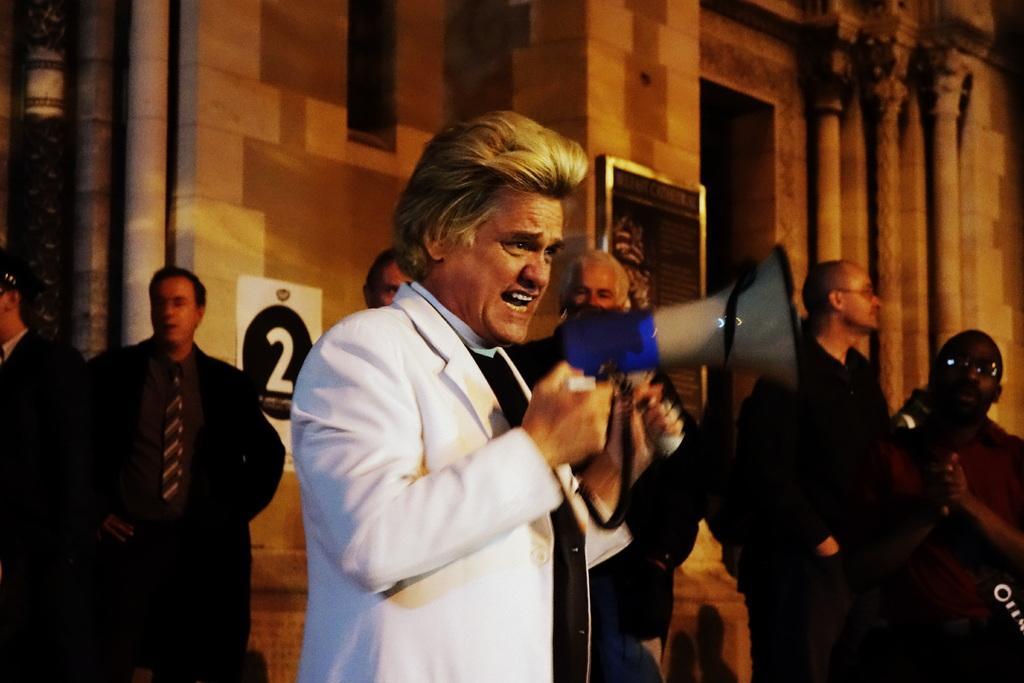In one or two sentences, can you explain what this image depicts? There is one person standing and wearing a white color blazer and holding a Mic at the bottom of this image. There are some persons standing behind this person. There is a building in the background. 